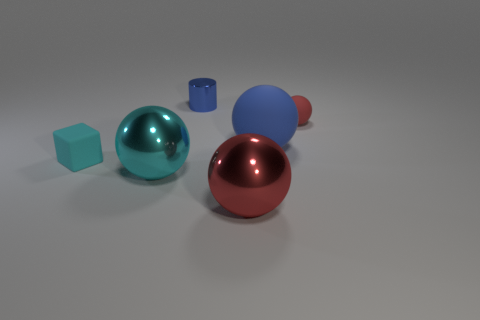Subtract all cyan spheres. How many spheres are left? 3 Subtract all purple cylinders. How many red spheres are left? 2 Add 2 large blue rubber things. How many objects exist? 8 Subtract all cyan balls. How many balls are left? 3 Subtract all blocks. How many objects are left? 5 Subtract all yellow balls. Subtract all cyan blocks. How many balls are left? 4 Add 4 big cyan things. How many big cyan things exist? 5 Subtract 0 red cubes. How many objects are left? 6 Subtract all big yellow metal objects. Subtract all red rubber balls. How many objects are left? 5 Add 6 tiny things. How many tiny things are left? 9 